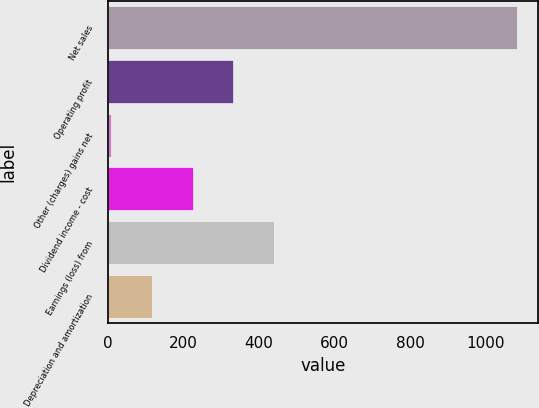<chart> <loc_0><loc_0><loc_500><loc_500><bar_chart><fcel>Net sales<fcel>Operating profit<fcel>Other (charges) gains net<fcel>Dividend income - cost<fcel>Earnings (loss) from<fcel>Depreciation and amortization<nl><fcel>1084<fcel>331.5<fcel>9<fcel>224<fcel>439<fcel>116.5<nl></chart> 